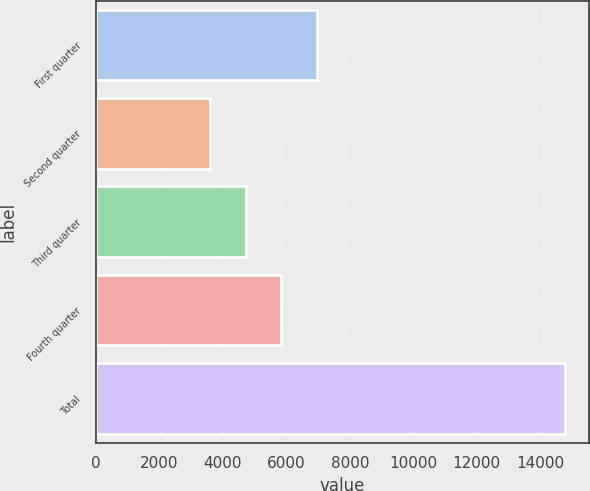Convert chart. <chart><loc_0><loc_0><loc_500><loc_500><bar_chart><fcel>First quarter<fcel>Second quarter<fcel>Third quarter<fcel>Fourth quarter<fcel>Total<nl><fcel>6960<fcel>3600<fcel>4720<fcel>5840<fcel>14800<nl></chart> 